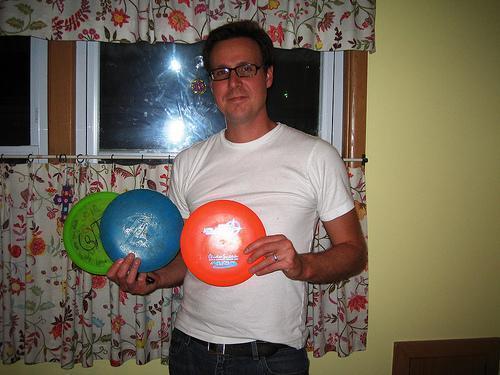How many Frisbees are there?
Give a very brief answer. 3. 